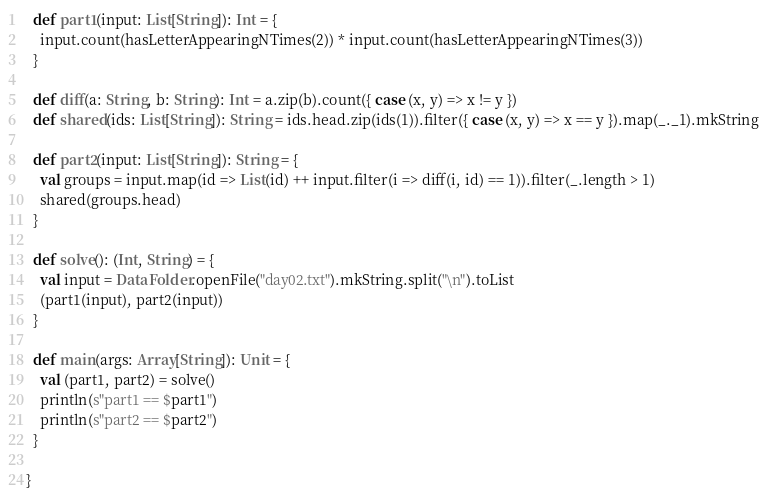Convert code to text. <code><loc_0><loc_0><loc_500><loc_500><_Scala_>
  def part1(input: List[String]): Int = {
    input.count(hasLetterAppearingNTimes(2)) * input.count(hasLetterAppearingNTimes(3))
  }

  def diff(a: String, b: String): Int = a.zip(b).count({ case (x, y) => x != y })
  def shared(ids: List[String]): String = ids.head.zip(ids(1)).filter({ case (x, y) => x == y }).map(_._1).mkString

  def part2(input: List[String]): String = {
    val groups = input.map(id => List(id) ++ input.filter(i => diff(i, id) == 1)).filter(_.length > 1)
    shared(groups.head)
  }

  def solve(): (Int, String) = {
    val input = DataFolder.openFile("day02.txt").mkString.split("\n").toList
    (part1(input), part2(input))
  }

  def main(args: Array[String]): Unit = {
    val (part1, part2) = solve()
    println(s"part1 == $part1")
    println(s"part2 == $part2")
  }

}
</code> 